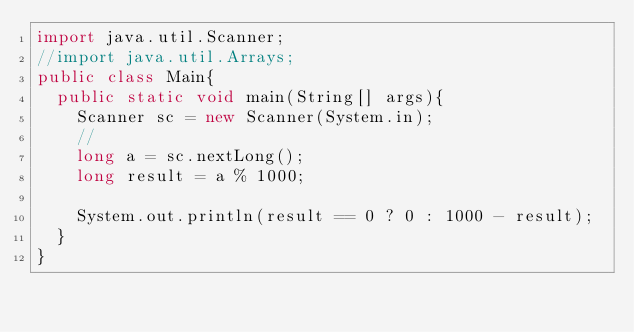<code> <loc_0><loc_0><loc_500><loc_500><_Java_>import java.util.Scanner;
//import java.util.Arrays;
public class Main{
	public static void main(String[] args){
		Scanner sc = new Scanner(System.in);
		//
		long a = sc.nextLong();
		long result = a % 1000;
		
		System.out.println(result == 0 ? 0 : 1000 - result);
	}
}
</code> 